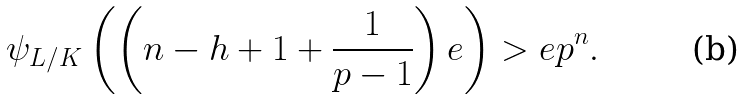<formula> <loc_0><loc_0><loc_500><loc_500>\psi _ { L / K } \left ( \left ( n - h + 1 + \frac { 1 } { p - 1 } \right ) e \right ) > e p ^ { n } .</formula> 